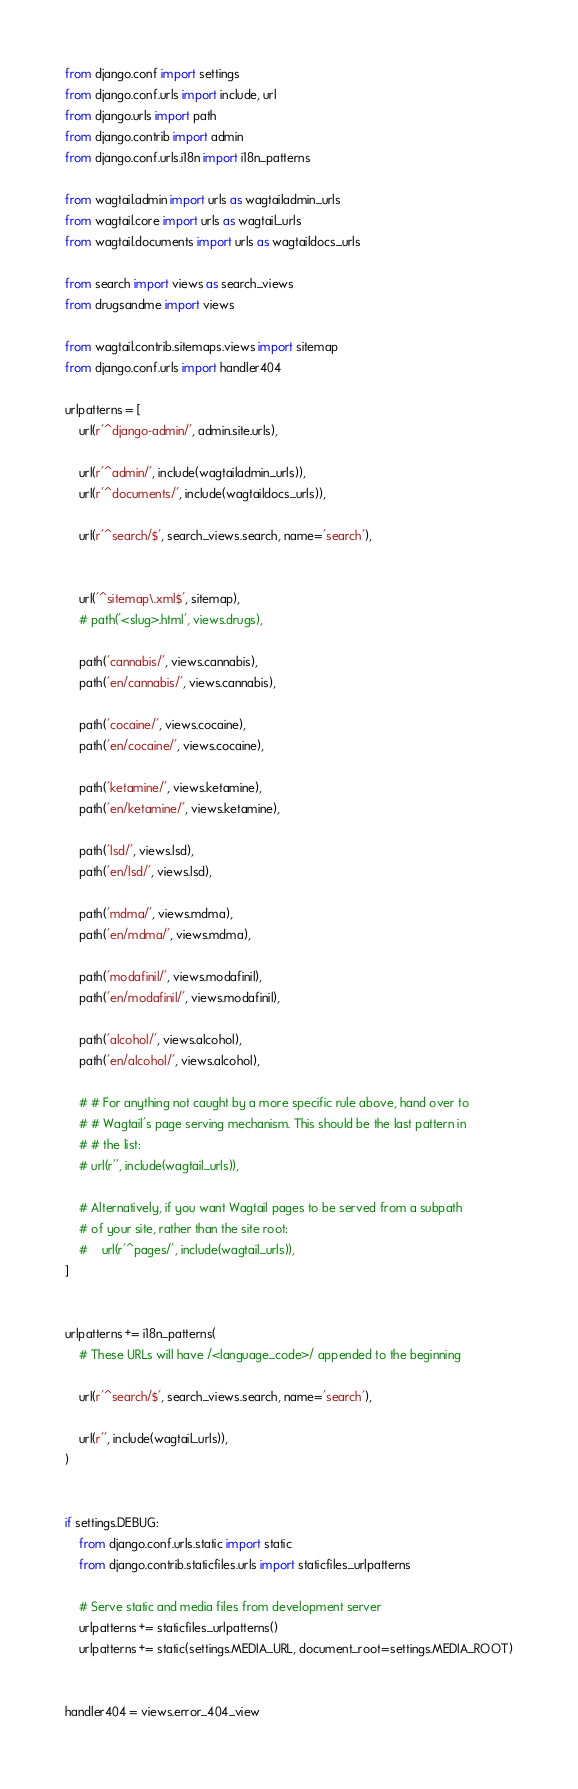<code> <loc_0><loc_0><loc_500><loc_500><_Python_>from django.conf import settings
from django.conf.urls import include, url
from django.urls import path
from django.contrib import admin
from django.conf.urls.i18n import i18n_patterns

from wagtail.admin import urls as wagtailadmin_urls
from wagtail.core import urls as wagtail_urls
from wagtail.documents import urls as wagtaildocs_urls

from search import views as search_views
from drugsandme import views

from wagtail.contrib.sitemaps.views import sitemap
from django.conf.urls import handler404

urlpatterns = [
    url(r'^django-admin/', admin.site.urls),

    url(r'^admin/', include(wagtailadmin_urls)),
    url(r'^documents/', include(wagtaildocs_urls)),

    url(r'^search/$', search_views.search, name='search'),


    url('^sitemap\.xml$', sitemap),
    # path('<slug>.html', views.drugs),

    path('cannabis/', views.cannabis),
    path('en/cannabis/', views.cannabis),

    path('cocaine/', views.cocaine),
    path('en/cocaine/', views.cocaine),

    path('ketamine/', views.ketamine),
    path('en/ketamine/', views.ketamine),

    path('lsd/', views.lsd),
    path('en/lsd/', views.lsd),

    path('mdma/', views.mdma),
    path('en/mdma/', views.mdma),

    path('modafinil/', views.modafinil),
    path('en/modafinil/', views.modafinil),

    path('alcohol/', views.alcohol),
    path('en/alcohol/', views.alcohol),

    # # For anything not caught by a more specific rule above, hand over to
    # # Wagtail's page serving mechanism. This should be the last pattern in
    # # the list:
    # url(r'', include(wagtail_urls)),

    # Alternatively, if you want Wagtail pages to be served from a subpath
    # of your site, rather than the site root:
    #    url(r'^pages/', include(wagtail_urls)),
]


urlpatterns += i18n_patterns(
    # These URLs will have /<language_code>/ appended to the beginning

    url(r'^search/$', search_views.search, name='search'),

    url(r'', include(wagtail_urls)),
)


if settings.DEBUG:
    from django.conf.urls.static import static
    from django.contrib.staticfiles.urls import staticfiles_urlpatterns

    # Serve static and media files from development server
    urlpatterns += staticfiles_urlpatterns()
    urlpatterns += static(settings.MEDIA_URL, document_root=settings.MEDIA_ROOT)


handler404 = views.error_404_view</code> 